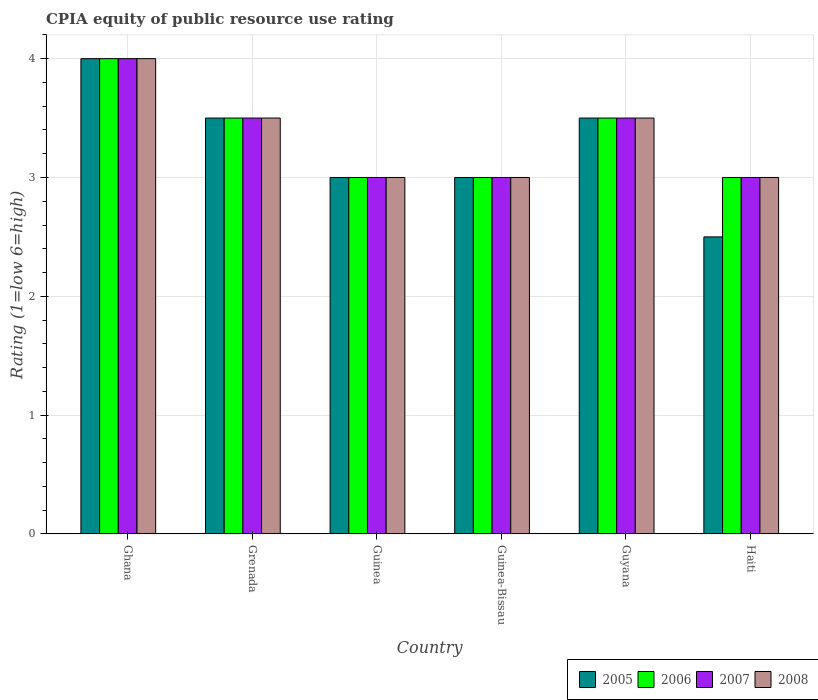How many groups of bars are there?
Provide a short and direct response. 6. Are the number of bars per tick equal to the number of legend labels?
Your response must be concise. Yes. Are the number of bars on each tick of the X-axis equal?
Provide a short and direct response. Yes. How many bars are there on the 3rd tick from the left?
Ensure brevity in your answer.  4. How many bars are there on the 5th tick from the right?
Provide a short and direct response. 4. What is the label of the 4th group of bars from the left?
Make the answer very short. Guinea-Bissau. In which country was the CPIA rating in 2008 maximum?
Provide a succinct answer. Ghana. In which country was the CPIA rating in 2006 minimum?
Give a very brief answer. Guinea. What is the total CPIA rating in 2006 in the graph?
Ensure brevity in your answer.  20. What is the difference between the CPIA rating in 2005 in Grenada and the CPIA rating in 2006 in Ghana?
Offer a terse response. -0.5. What is the average CPIA rating in 2008 per country?
Offer a terse response. 3.33. What is the difference between the CPIA rating of/in 2008 and CPIA rating of/in 2007 in Haiti?
Offer a very short reply. 0. Is the CPIA rating in 2006 in Guinea less than that in Haiti?
Offer a very short reply. No. What is the difference between the highest and the second highest CPIA rating in 2006?
Offer a very short reply. -0.5. In how many countries, is the CPIA rating in 2005 greater than the average CPIA rating in 2005 taken over all countries?
Offer a very short reply. 3. Is it the case that in every country, the sum of the CPIA rating in 2007 and CPIA rating in 2006 is greater than the sum of CPIA rating in 2008 and CPIA rating in 2005?
Keep it short and to the point. No. Is it the case that in every country, the sum of the CPIA rating in 2007 and CPIA rating in 2008 is greater than the CPIA rating in 2005?
Provide a succinct answer. Yes. How many countries are there in the graph?
Keep it short and to the point. 6. What is the difference between two consecutive major ticks on the Y-axis?
Offer a very short reply. 1. Does the graph contain any zero values?
Your response must be concise. No. Where does the legend appear in the graph?
Ensure brevity in your answer.  Bottom right. How are the legend labels stacked?
Give a very brief answer. Horizontal. What is the title of the graph?
Your answer should be compact. CPIA equity of public resource use rating. Does "1991" appear as one of the legend labels in the graph?
Offer a terse response. No. What is the Rating (1=low 6=high) of 2005 in Ghana?
Your response must be concise. 4. What is the Rating (1=low 6=high) in 2006 in Ghana?
Offer a terse response. 4. What is the Rating (1=low 6=high) in 2007 in Ghana?
Keep it short and to the point. 4. What is the Rating (1=low 6=high) in 2008 in Ghana?
Give a very brief answer. 4. What is the Rating (1=low 6=high) in 2006 in Guinea?
Make the answer very short. 3. What is the Rating (1=low 6=high) in 2007 in Guinea?
Ensure brevity in your answer.  3. What is the Rating (1=low 6=high) in 2008 in Guinea?
Provide a succinct answer. 3. What is the Rating (1=low 6=high) in 2006 in Guyana?
Offer a terse response. 3.5. What is the Rating (1=low 6=high) in 2006 in Haiti?
Your response must be concise. 3. What is the Rating (1=low 6=high) of 2008 in Haiti?
Your answer should be compact. 3. Across all countries, what is the maximum Rating (1=low 6=high) in 2006?
Give a very brief answer. 4. Across all countries, what is the maximum Rating (1=low 6=high) of 2008?
Give a very brief answer. 4. Across all countries, what is the minimum Rating (1=low 6=high) of 2005?
Offer a terse response. 2.5. Across all countries, what is the minimum Rating (1=low 6=high) of 2006?
Your answer should be compact. 3. What is the total Rating (1=low 6=high) of 2006 in the graph?
Your answer should be very brief. 20. What is the total Rating (1=low 6=high) in 2008 in the graph?
Your response must be concise. 20. What is the difference between the Rating (1=low 6=high) of 2005 in Ghana and that in Grenada?
Keep it short and to the point. 0.5. What is the difference between the Rating (1=low 6=high) of 2006 in Ghana and that in Grenada?
Provide a short and direct response. 0.5. What is the difference between the Rating (1=low 6=high) in 2007 in Ghana and that in Grenada?
Keep it short and to the point. 0.5. What is the difference between the Rating (1=low 6=high) in 2008 in Ghana and that in Grenada?
Make the answer very short. 0.5. What is the difference between the Rating (1=low 6=high) in 2006 in Ghana and that in Guinea?
Ensure brevity in your answer.  1. What is the difference between the Rating (1=low 6=high) of 2008 in Ghana and that in Guinea?
Your response must be concise. 1. What is the difference between the Rating (1=low 6=high) of 2007 in Ghana and that in Guinea-Bissau?
Provide a succinct answer. 1. What is the difference between the Rating (1=low 6=high) in 2005 in Ghana and that in Guyana?
Ensure brevity in your answer.  0.5. What is the difference between the Rating (1=low 6=high) of 2006 in Ghana and that in Guyana?
Your answer should be very brief. 0.5. What is the difference between the Rating (1=low 6=high) of 2007 in Ghana and that in Guyana?
Offer a terse response. 0.5. What is the difference between the Rating (1=low 6=high) in 2005 in Ghana and that in Haiti?
Provide a short and direct response. 1.5. What is the difference between the Rating (1=low 6=high) in 2008 in Ghana and that in Haiti?
Keep it short and to the point. 1. What is the difference between the Rating (1=low 6=high) of 2007 in Grenada and that in Guinea?
Provide a succinct answer. 0.5. What is the difference between the Rating (1=low 6=high) in 2008 in Grenada and that in Guinea?
Make the answer very short. 0.5. What is the difference between the Rating (1=low 6=high) of 2005 in Grenada and that in Guinea-Bissau?
Your answer should be compact. 0.5. What is the difference between the Rating (1=low 6=high) of 2006 in Grenada and that in Guinea-Bissau?
Offer a terse response. 0.5. What is the difference between the Rating (1=low 6=high) in 2007 in Grenada and that in Guinea-Bissau?
Ensure brevity in your answer.  0.5. What is the difference between the Rating (1=low 6=high) of 2008 in Grenada and that in Guinea-Bissau?
Make the answer very short. 0.5. What is the difference between the Rating (1=low 6=high) in 2007 in Grenada and that in Guyana?
Give a very brief answer. 0. What is the difference between the Rating (1=low 6=high) of 2008 in Grenada and that in Guyana?
Ensure brevity in your answer.  0. What is the difference between the Rating (1=low 6=high) in 2008 in Guinea and that in Guinea-Bissau?
Provide a succinct answer. 0. What is the difference between the Rating (1=low 6=high) of 2008 in Guinea and that in Guyana?
Give a very brief answer. -0.5. What is the difference between the Rating (1=low 6=high) in 2006 in Guinea-Bissau and that in Guyana?
Your answer should be very brief. -0.5. What is the difference between the Rating (1=low 6=high) in 2005 in Guinea-Bissau and that in Haiti?
Offer a very short reply. 0.5. What is the difference between the Rating (1=low 6=high) of 2006 in Guinea-Bissau and that in Haiti?
Provide a succinct answer. 0. What is the difference between the Rating (1=low 6=high) in 2007 in Guinea-Bissau and that in Haiti?
Keep it short and to the point. 0. What is the difference between the Rating (1=low 6=high) in 2005 in Ghana and the Rating (1=low 6=high) in 2007 in Grenada?
Provide a succinct answer. 0.5. What is the difference between the Rating (1=low 6=high) in 2005 in Ghana and the Rating (1=low 6=high) in 2008 in Grenada?
Make the answer very short. 0.5. What is the difference between the Rating (1=low 6=high) of 2005 in Ghana and the Rating (1=low 6=high) of 2006 in Guinea?
Provide a succinct answer. 1. What is the difference between the Rating (1=low 6=high) of 2006 in Ghana and the Rating (1=low 6=high) of 2007 in Guinea?
Offer a very short reply. 1. What is the difference between the Rating (1=low 6=high) of 2005 in Ghana and the Rating (1=low 6=high) of 2007 in Guinea-Bissau?
Ensure brevity in your answer.  1. What is the difference between the Rating (1=low 6=high) of 2006 in Ghana and the Rating (1=low 6=high) of 2007 in Guinea-Bissau?
Ensure brevity in your answer.  1. What is the difference between the Rating (1=low 6=high) of 2006 in Ghana and the Rating (1=low 6=high) of 2008 in Guinea-Bissau?
Ensure brevity in your answer.  1. What is the difference between the Rating (1=low 6=high) of 2007 in Ghana and the Rating (1=low 6=high) of 2008 in Guinea-Bissau?
Ensure brevity in your answer.  1. What is the difference between the Rating (1=low 6=high) in 2005 in Ghana and the Rating (1=low 6=high) in 2006 in Guyana?
Your answer should be compact. 0.5. What is the difference between the Rating (1=low 6=high) of 2005 in Ghana and the Rating (1=low 6=high) of 2007 in Guyana?
Offer a terse response. 0.5. What is the difference between the Rating (1=low 6=high) of 2005 in Ghana and the Rating (1=low 6=high) of 2008 in Guyana?
Make the answer very short. 0.5. What is the difference between the Rating (1=low 6=high) of 2006 in Ghana and the Rating (1=low 6=high) of 2008 in Guyana?
Offer a terse response. 0.5. What is the difference between the Rating (1=low 6=high) in 2007 in Ghana and the Rating (1=low 6=high) in 2008 in Guyana?
Offer a terse response. 0.5. What is the difference between the Rating (1=low 6=high) in 2007 in Ghana and the Rating (1=low 6=high) in 2008 in Haiti?
Your answer should be very brief. 1. What is the difference between the Rating (1=low 6=high) in 2005 in Grenada and the Rating (1=low 6=high) in 2008 in Guinea?
Ensure brevity in your answer.  0.5. What is the difference between the Rating (1=low 6=high) of 2006 in Grenada and the Rating (1=low 6=high) of 2007 in Guinea?
Offer a very short reply. 0.5. What is the difference between the Rating (1=low 6=high) in 2006 in Grenada and the Rating (1=low 6=high) in 2008 in Guinea?
Provide a short and direct response. 0.5. What is the difference between the Rating (1=low 6=high) in 2005 in Grenada and the Rating (1=low 6=high) in 2006 in Guinea-Bissau?
Provide a succinct answer. 0.5. What is the difference between the Rating (1=low 6=high) of 2005 in Grenada and the Rating (1=low 6=high) of 2008 in Guinea-Bissau?
Give a very brief answer. 0.5. What is the difference between the Rating (1=low 6=high) in 2005 in Grenada and the Rating (1=low 6=high) in 2006 in Guyana?
Offer a terse response. 0. What is the difference between the Rating (1=low 6=high) in 2005 in Grenada and the Rating (1=low 6=high) in 2008 in Guyana?
Ensure brevity in your answer.  0. What is the difference between the Rating (1=low 6=high) in 2006 in Grenada and the Rating (1=low 6=high) in 2007 in Guyana?
Provide a short and direct response. 0. What is the difference between the Rating (1=low 6=high) in 2005 in Grenada and the Rating (1=low 6=high) in 2008 in Haiti?
Keep it short and to the point. 0.5. What is the difference between the Rating (1=low 6=high) of 2006 in Grenada and the Rating (1=low 6=high) of 2007 in Haiti?
Offer a very short reply. 0.5. What is the difference between the Rating (1=low 6=high) of 2006 in Guinea and the Rating (1=low 6=high) of 2008 in Guinea-Bissau?
Ensure brevity in your answer.  0. What is the difference between the Rating (1=low 6=high) of 2007 in Guinea and the Rating (1=low 6=high) of 2008 in Guinea-Bissau?
Your answer should be very brief. 0. What is the difference between the Rating (1=low 6=high) of 2006 in Guinea and the Rating (1=low 6=high) of 2007 in Guyana?
Provide a short and direct response. -0.5. What is the difference between the Rating (1=low 6=high) of 2006 in Guinea and the Rating (1=low 6=high) of 2008 in Guyana?
Keep it short and to the point. -0.5. What is the difference between the Rating (1=low 6=high) of 2007 in Guinea and the Rating (1=low 6=high) of 2008 in Guyana?
Provide a succinct answer. -0.5. What is the difference between the Rating (1=low 6=high) of 2005 in Guinea and the Rating (1=low 6=high) of 2006 in Haiti?
Your response must be concise. 0. What is the difference between the Rating (1=low 6=high) of 2005 in Guinea and the Rating (1=low 6=high) of 2007 in Haiti?
Offer a terse response. 0. What is the difference between the Rating (1=low 6=high) in 2006 in Guinea and the Rating (1=low 6=high) in 2007 in Haiti?
Give a very brief answer. 0. What is the difference between the Rating (1=low 6=high) of 2005 in Guinea-Bissau and the Rating (1=low 6=high) of 2006 in Guyana?
Provide a succinct answer. -0.5. What is the difference between the Rating (1=low 6=high) in 2005 in Guinea-Bissau and the Rating (1=low 6=high) in 2007 in Guyana?
Your response must be concise. -0.5. What is the difference between the Rating (1=low 6=high) of 2005 in Guinea-Bissau and the Rating (1=low 6=high) of 2007 in Haiti?
Provide a succinct answer. 0. What is the difference between the Rating (1=low 6=high) in 2006 in Guinea-Bissau and the Rating (1=low 6=high) in 2007 in Haiti?
Give a very brief answer. 0. What is the difference between the Rating (1=low 6=high) in 2007 in Guinea-Bissau and the Rating (1=low 6=high) in 2008 in Haiti?
Ensure brevity in your answer.  0. What is the difference between the Rating (1=low 6=high) of 2006 in Guyana and the Rating (1=low 6=high) of 2008 in Haiti?
Your answer should be very brief. 0.5. What is the difference between the Rating (1=low 6=high) in 2007 in Guyana and the Rating (1=low 6=high) in 2008 in Haiti?
Provide a succinct answer. 0.5. What is the average Rating (1=low 6=high) in 2006 per country?
Your response must be concise. 3.33. What is the difference between the Rating (1=low 6=high) in 2005 and Rating (1=low 6=high) in 2007 in Ghana?
Make the answer very short. 0. What is the difference between the Rating (1=low 6=high) of 2005 and Rating (1=low 6=high) of 2008 in Ghana?
Ensure brevity in your answer.  0. What is the difference between the Rating (1=low 6=high) of 2006 and Rating (1=low 6=high) of 2007 in Ghana?
Provide a succinct answer. 0. What is the difference between the Rating (1=low 6=high) of 2005 and Rating (1=low 6=high) of 2006 in Grenada?
Your answer should be very brief. 0. What is the difference between the Rating (1=low 6=high) of 2005 and Rating (1=low 6=high) of 2007 in Grenada?
Make the answer very short. 0. What is the difference between the Rating (1=low 6=high) of 2005 and Rating (1=low 6=high) of 2008 in Grenada?
Provide a succinct answer. 0. What is the difference between the Rating (1=low 6=high) in 2006 and Rating (1=low 6=high) in 2007 in Grenada?
Your answer should be compact. 0. What is the difference between the Rating (1=low 6=high) in 2007 and Rating (1=low 6=high) in 2008 in Grenada?
Your answer should be very brief. 0. What is the difference between the Rating (1=low 6=high) in 2006 and Rating (1=low 6=high) in 2007 in Guinea?
Your answer should be very brief. 0. What is the difference between the Rating (1=low 6=high) of 2006 and Rating (1=low 6=high) of 2008 in Guinea?
Offer a terse response. 0. What is the difference between the Rating (1=low 6=high) in 2007 and Rating (1=low 6=high) in 2008 in Guinea?
Give a very brief answer. 0. What is the difference between the Rating (1=low 6=high) of 2005 and Rating (1=low 6=high) of 2007 in Guinea-Bissau?
Offer a very short reply. 0. What is the difference between the Rating (1=low 6=high) of 2005 and Rating (1=low 6=high) of 2008 in Guinea-Bissau?
Give a very brief answer. 0. What is the difference between the Rating (1=low 6=high) of 2006 and Rating (1=low 6=high) of 2008 in Guinea-Bissau?
Keep it short and to the point. 0. What is the difference between the Rating (1=low 6=high) in 2007 and Rating (1=low 6=high) in 2008 in Guinea-Bissau?
Ensure brevity in your answer.  0. What is the difference between the Rating (1=low 6=high) in 2005 and Rating (1=low 6=high) in 2007 in Guyana?
Ensure brevity in your answer.  0. What is the difference between the Rating (1=low 6=high) in 2005 and Rating (1=low 6=high) in 2008 in Guyana?
Provide a short and direct response. 0. What is the difference between the Rating (1=low 6=high) in 2006 and Rating (1=low 6=high) in 2007 in Guyana?
Keep it short and to the point. 0. What is the ratio of the Rating (1=low 6=high) of 2007 in Ghana to that in Grenada?
Give a very brief answer. 1.14. What is the ratio of the Rating (1=low 6=high) in 2005 in Ghana to that in Guinea?
Provide a short and direct response. 1.33. What is the ratio of the Rating (1=low 6=high) in 2006 in Ghana to that in Guinea?
Provide a succinct answer. 1.33. What is the ratio of the Rating (1=low 6=high) of 2007 in Ghana to that in Guinea?
Offer a very short reply. 1.33. What is the ratio of the Rating (1=low 6=high) of 2006 in Ghana to that in Guinea-Bissau?
Provide a succinct answer. 1.33. What is the ratio of the Rating (1=low 6=high) of 2007 in Ghana to that in Guinea-Bissau?
Provide a succinct answer. 1.33. What is the ratio of the Rating (1=low 6=high) of 2008 in Ghana to that in Guyana?
Ensure brevity in your answer.  1.14. What is the ratio of the Rating (1=low 6=high) of 2005 in Ghana to that in Haiti?
Give a very brief answer. 1.6. What is the ratio of the Rating (1=low 6=high) of 2008 in Ghana to that in Haiti?
Ensure brevity in your answer.  1.33. What is the ratio of the Rating (1=low 6=high) of 2005 in Grenada to that in Guinea?
Keep it short and to the point. 1.17. What is the ratio of the Rating (1=low 6=high) of 2007 in Grenada to that in Guinea?
Your answer should be very brief. 1.17. What is the ratio of the Rating (1=low 6=high) of 2005 in Grenada to that in Guinea-Bissau?
Give a very brief answer. 1.17. What is the ratio of the Rating (1=low 6=high) of 2008 in Grenada to that in Guinea-Bissau?
Your response must be concise. 1.17. What is the ratio of the Rating (1=low 6=high) in 2006 in Grenada to that in Guyana?
Offer a very short reply. 1. What is the ratio of the Rating (1=low 6=high) in 2008 in Grenada to that in Guyana?
Provide a short and direct response. 1. What is the ratio of the Rating (1=low 6=high) in 2006 in Grenada to that in Haiti?
Offer a terse response. 1.17. What is the ratio of the Rating (1=low 6=high) in 2007 in Guinea to that in Guinea-Bissau?
Give a very brief answer. 1. What is the ratio of the Rating (1=low 6=high) of 2005 in Guinea to that in Guyana?
Your answer should be very brief. 0.86. What is the ratio of the Rating (1=low 6=high) of 2007 in Guinea to that in Guyana?
Make the answer very short. 0.86. What is the ratio of the Rating (1=low 6=high) of 2005 in Guinea to that in Haiti?
Make the answer very short. 1.2. What is the ratio of the Rating (1=low 6=high) in 2006 in Guinea to that in Haiti?
Keep it short and to the point. 1. What is the ratio of the Rating (1=low 6=high) in 2007 in Guinea to that in Haiti?
Your answer should be very brief. 1. What is the ratio of the Rating (1=low 6=high) in 2008 in Guinea to that in Haiti?
Offer a terse response. 1. What is the ratio of the Rating (1=low 6=high) in 2005 in Guinea-Bissau to that in Guyana?
Give a very brief answer. 0.86. What is the ratio of the Rating (1=low 6=high) of 2006 in Guinea-Bissau to that in Guyana?
Give a very brief answer. 0.86. What is the ratio of the Rating (1=low 6=high) of 2007 in Guinea-Bissau to that in Guyana?
Keep it short and to the point. 0.86. What is the ratio of the Rating (1=low 6=high) of 2005 in Guinea-Bissau to that in Haiti?
Give a very brief answer. 1.2. What is the ratio of the Rating (1=low 6=high) in 2005 in Guyana to that in Haiti?
Your response must be concise. 1.4. What is the ratio of the Rating (1=low 6=high) of 2006 in Guyana to that in Haiti?
Offer a very short reply. 1.17. What is the ratio of the Rating (1=low 6=high) in 2007 in Guyana to that in Haiti?
Offer a terse response. 1.17. What is the ratio of the Rating (1=low 6=high) of 2008 in Guyana to that in Haiti?
Provide a short and direct response. 1.17. What is the difference between the highest and the lowest Rating (1=low 6=high) in 2005?
Your response must be concise. 1.5. 